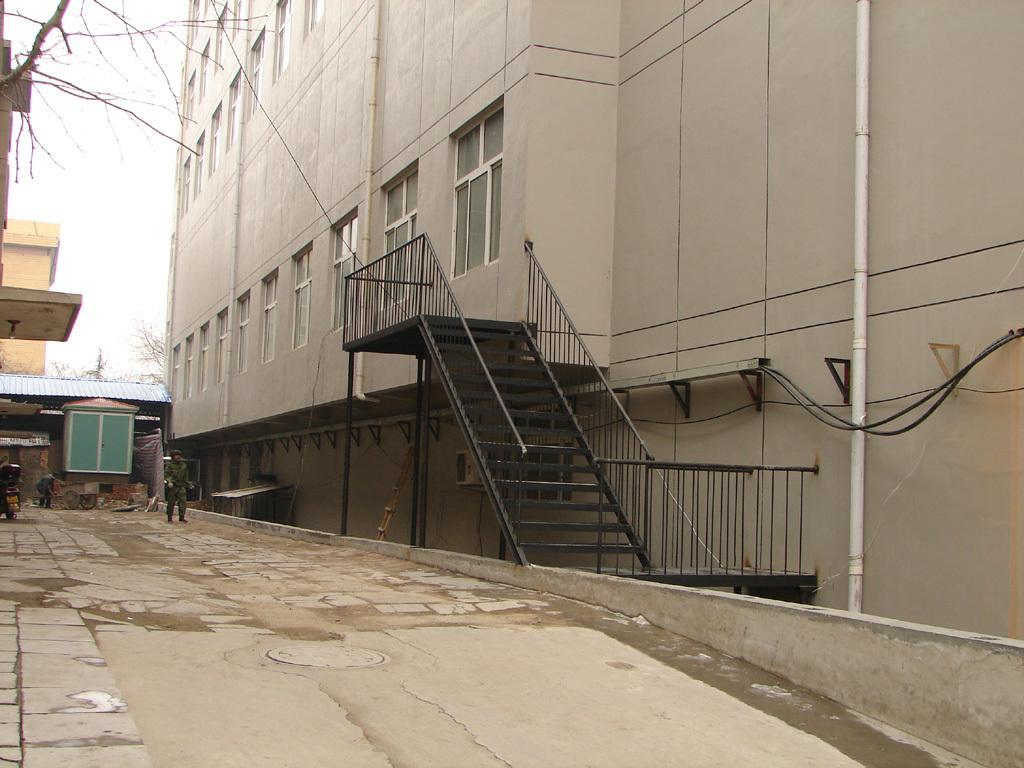Please provide a concise description of this image. In this image we can see two buildings and on the right side there is a building with stairway attached to it. We can see a person walking and in the background, we can see a hut and some other objects and there are some trees. 